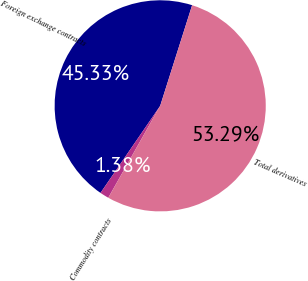Convert chart to OTSL. <chart><loc_0><loc_0><loc_500><loc_500><pie_chart><fcel>Foreign exchange contracts<fcel>Commodity contracts<fcel>Total derivatives<nl><fcel>45.33%<fcel>1.38%<fcel>53.29%<nl></chart> 